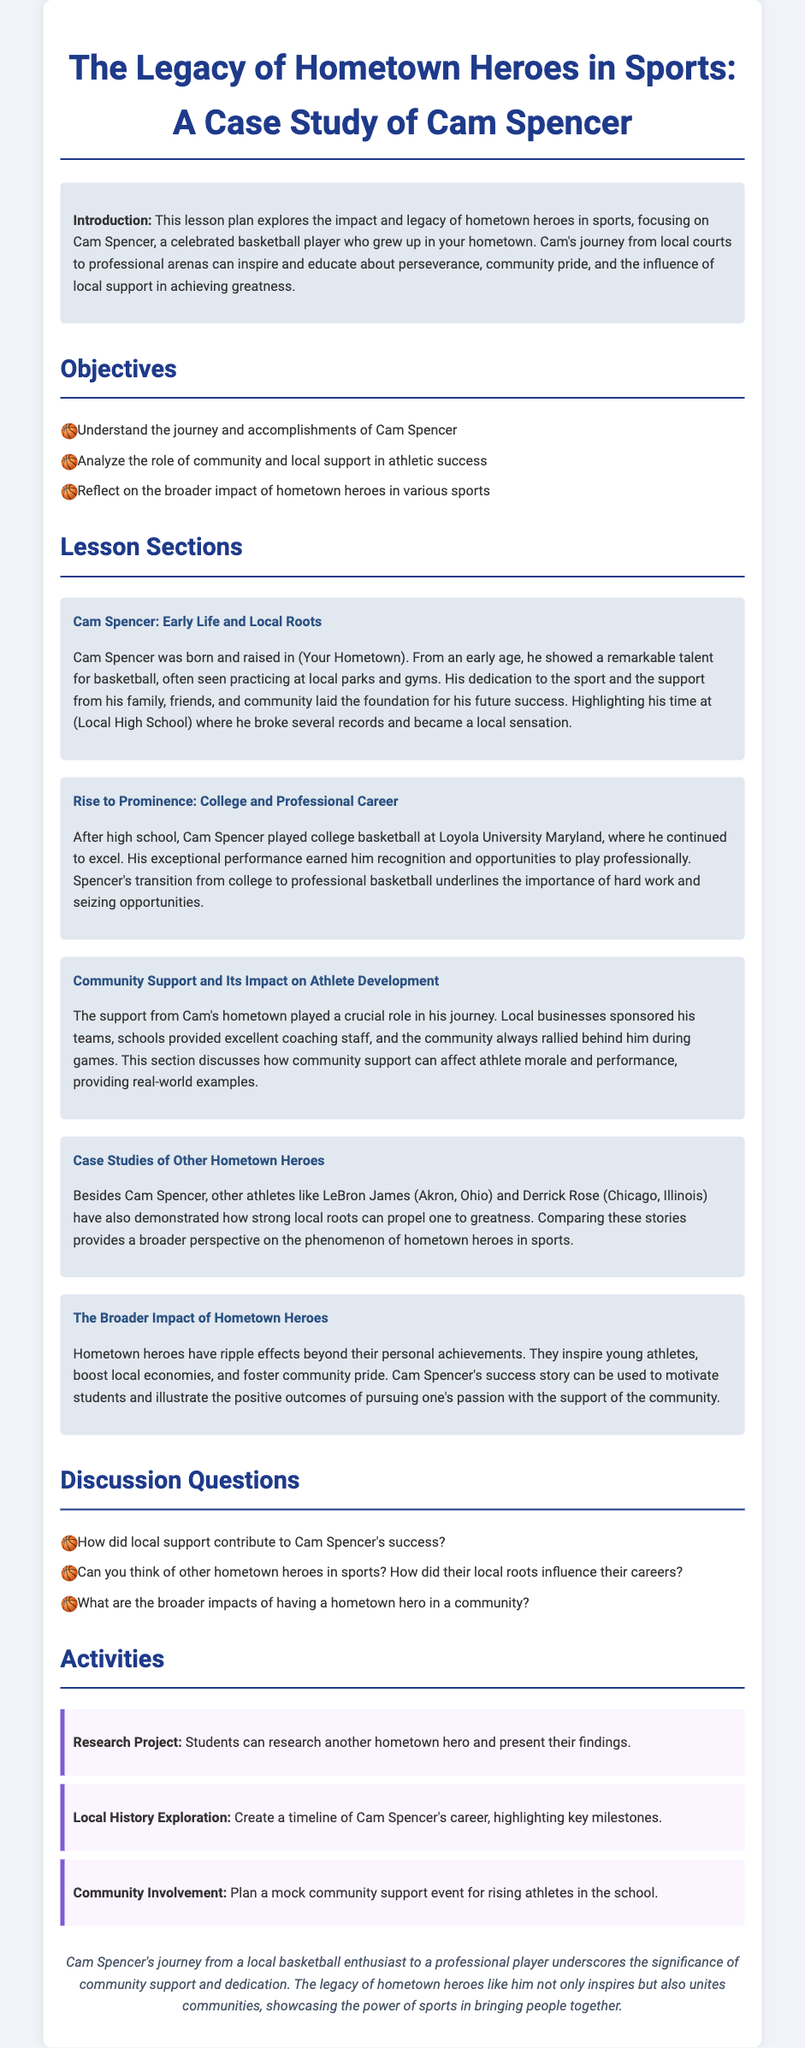What is the main focus of the lesson plan? The lesson plan focuses on the impact and legacy of hometown heroes in sports, specifically highlighting Cam Spencer's journey.
Answer: Hometown heroes in sports Who is highlighted as the main subject of this case study? The case study is centered around Cam Spencer, a basketball player from the hometown.
Answer: Cam Spencer What significant milestone did Cam Spencer achieve in high school? Cam Spencer broke several records during his time at local high school, becoming a local sensation.
Answer: Broke several records Which university did Cam Spencer attend for college basketball? He played college basketball at Loyola University Maryland, furthering his career.
Answer: Loyola University Maryland What is one example of how community support helped Cam Spencer? Local businesses sponsored his teams, which supported his development as an athlete.
Answer: Local businesses sponsored Name one other athlete compared to Cam Spencer in the document. The document mentions athletes like LeBron James and Derrick Rose as examples of hometown heroes.
Answer: LeBron James What type of project involves researching another hometown hero? The lesson plan includes a research project where students can explore the life of another hometown hero.
Answer: Research Project How can students show community involvement in the lesson plan? Students are encouraged to plan a mock community support event for rising athletes in school.
Answer: Mock community support event What are the broader impacts of having a hometown hero in a community? Hometown heroes inspire young athletes, boost local economies, and foster community pride.
Answer: Inspire young athletes, boost local economies, and foster community pride 